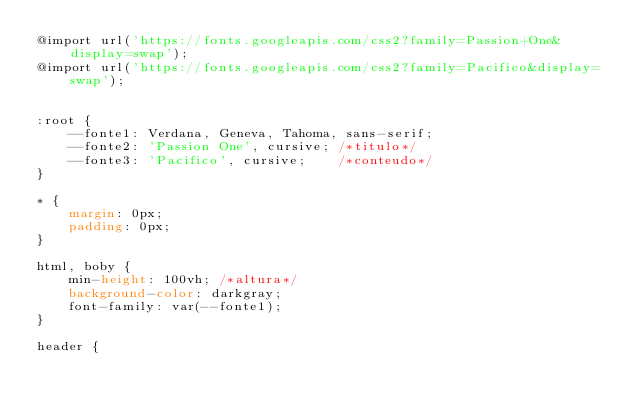Convert code to text. <code><loc_0><loc_0><loc_500><loc_500><_CSS_>@import url('https://fonts.googleapis.com/css2?family=Passion+One&display=swap');
@import url('https://fonts.googleapis.com/css2?family=Pacifico&display=swap');


:root {
    --fonte1: Verdana, Geneva, Tahoma, sans-serif;
    --fonte2: 'Passion One', cursive; /*titulo*/
    --fonte3: 'Pacifico', cursive;    /*conteudo*/
}

* {
    margin: 0px;
    padding: 0px;
}

html, boby {
    min-height: 100vh; /*altura*/
    background-color: darkgray;
    font-family: var(--fonte1);
}

header {</code> 